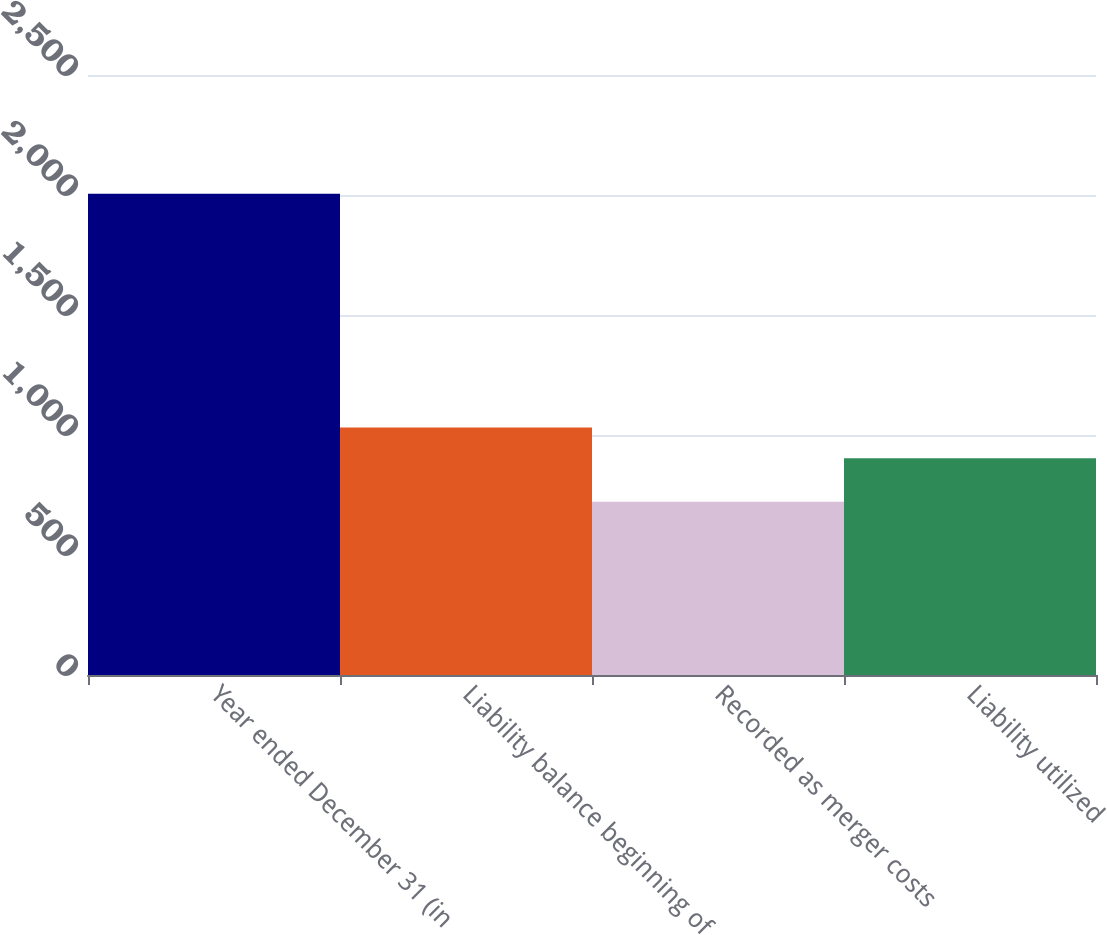Convert chart to OTSL. <chart><loc_0><loc_0><loc_500><loc_500><bar_chart><fcel>Year ended December 31 (in<fcel>Liability balance beginning of<fcel>Recorded as merger costs<fcel>Liability utilized<nl><fcel>2005<fcel>1031.3<fcel>722<fcel>903<nl></chart> 